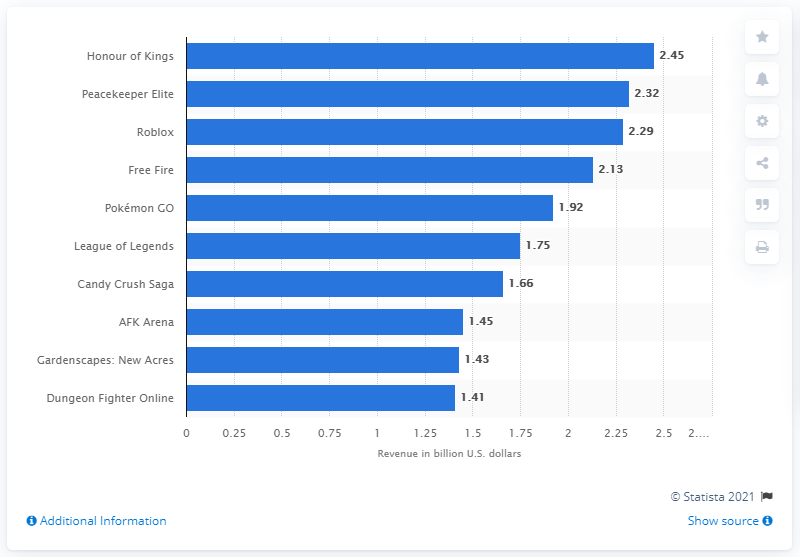List a handful of essential elements in this visual. Peacekeeper Elite generated $2.32 million in U.S. dollars. 